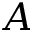Convert formula to latex. <formula><loc_0><loc_0><loc_500><loc_500>A</formula> 